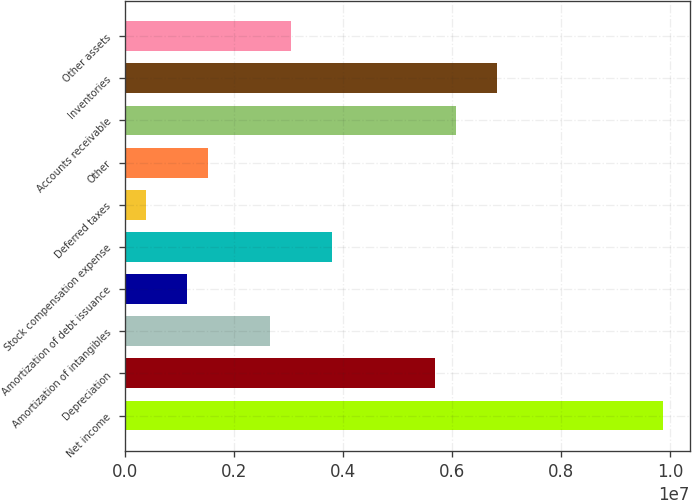<chart> <loc_0><loc_0><loc_500><loc_500><bar_chart><fcel>Net income<fcel>Depreciation<fcel>Amortization of intangibles<fcel>Amortization of debt issuance<fcel>Stock compensation expense<fcel>Deferred taxes<fcel>Other<fcel>Accounts receivable<fcel>Inventories<fcel>Other assets<nl><fcel>9.86542e+06<fcel>5.69472e+06<fcel>2.66148e+06<fcel>1.14486e+06<fcel>3.79894e+06<fcel>386551<fcel>1.52401e+06<fcel>6.07387e+06<fcel>6.83218e+06<fcel>3.04063e+06<nl></chart> 